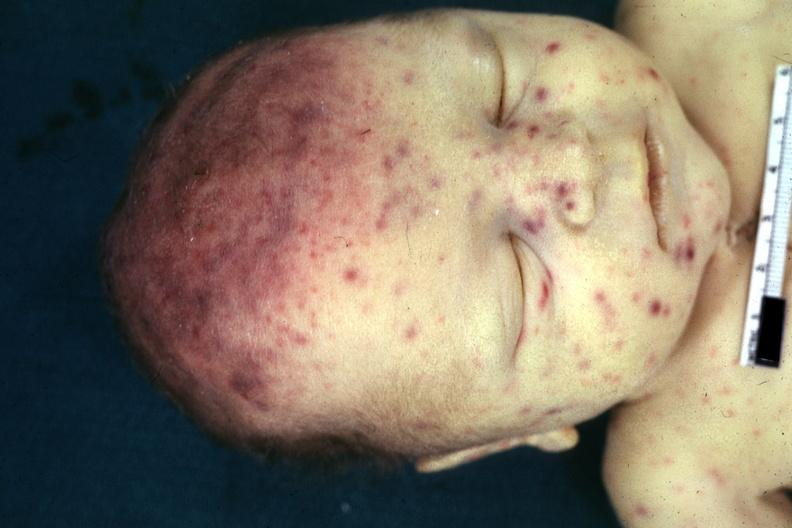does wonder show face jaundice and multiple petechial and purpuric hemorrhages?
Answer the question using a single word or phrase. No 